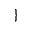Convert formula to latex. <formula><loc_0><loc_0><loc_500><loc_500>\}</formula> 